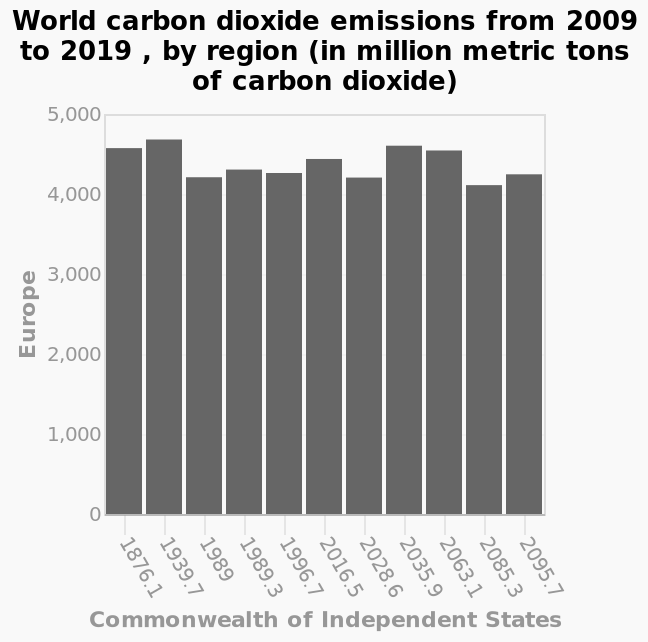<image>
Which region experienced a sharp rise in market share for internet browsers between 2014 and 2018?  Europe What is the time period covered in the bar plot? The bar plot covers the time period from 2009 to 2019. 